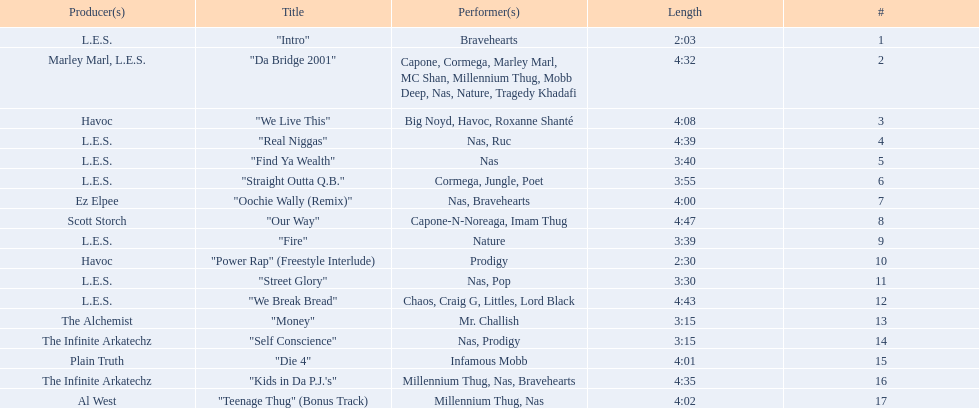Who produced the last track of the album? Al West. 